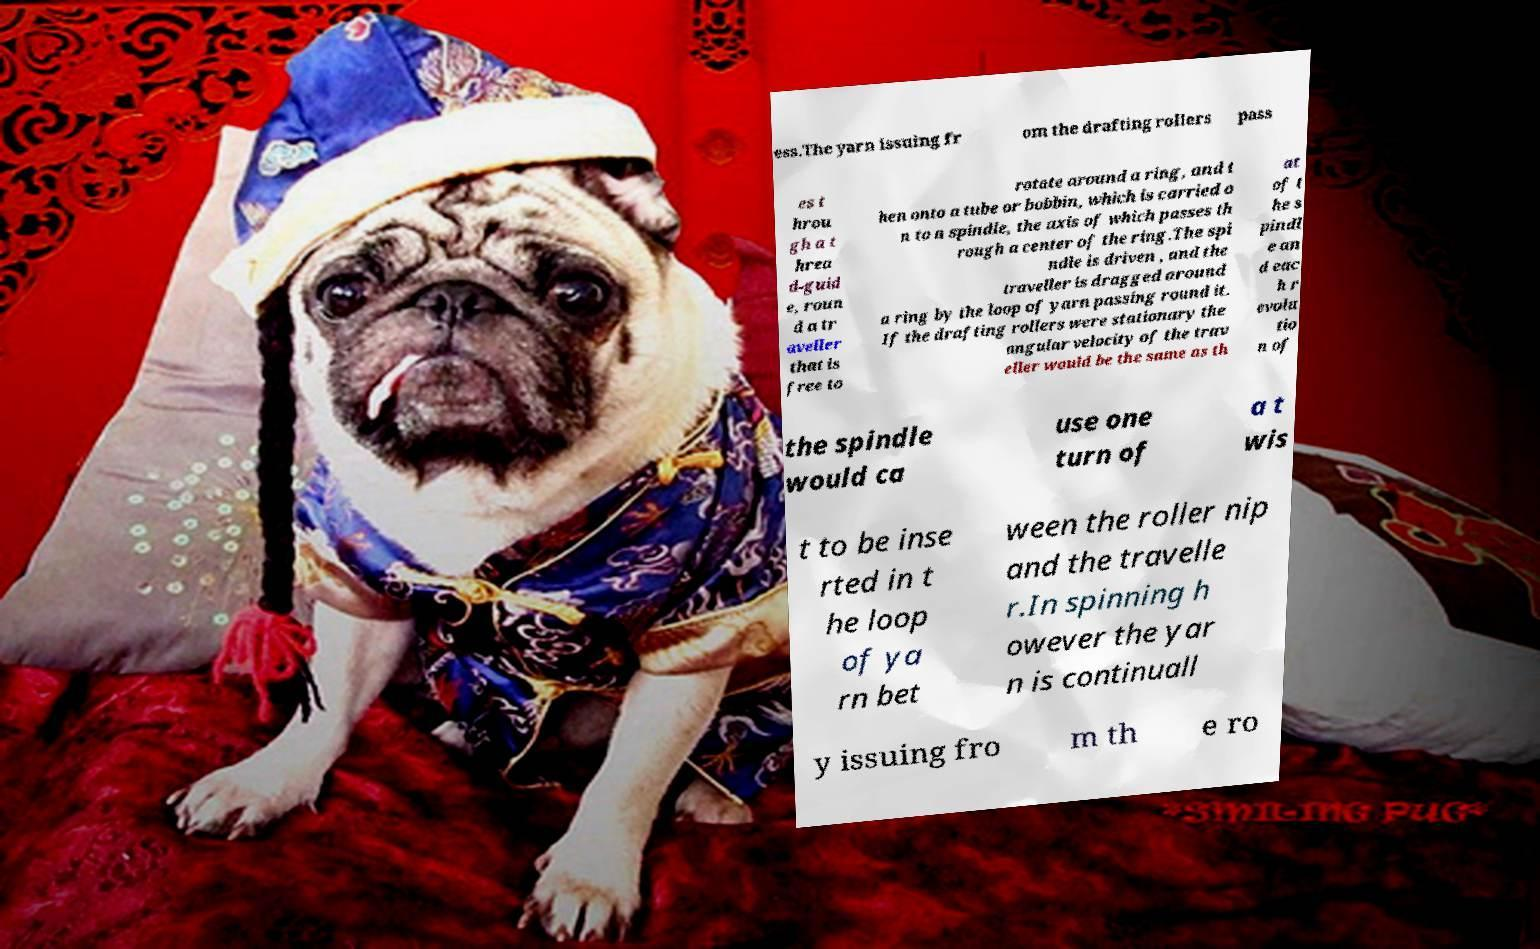I need the written content from this picture converted into text. Can you do that? ess.The yarn issuing fr om the drafting rollers pass es t hrou gh a t hrea d-guid e, roun d a tr aveller that is free to rotate around a ring, and t hen onto a tube or bobbin, which is carried o n to a spindle, the axis of which passes th rough a center of the ring.The spi ndle is driven , and the traveller is dragged around a ring by the loop of yarn passing round it. If the drafting rollers were stationary the angular velocity of the trav eller would be the same as th at of t he s pindl e an d eac h r evolu tio n of the spindle would ca use one turn of a t wis t to be inse rted in t he loop of ya rn bet ween the roller nip and the travelle r.In spinning h owever the yar n is continuall y issuing fro m th e ro 